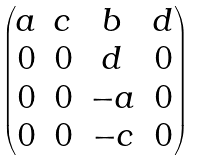<formula> <loc_0><loc_0><loc_500><loc_500>\begin{pmatrix} a & c & b & d \\ 0 & 0 & d & 0 \\ 0 & 0 & - a & 0 \\ 0 & 0 & - c & 0 \\ \end{pmatrix}</formula> 